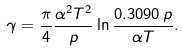Convert formula to latex. <formula><loc_0><loc_0><loc_500><loc_500>\gamma = \frac { \pi } { 4 } \frac { \alpha ^ { 2 } T ^ { 2 } } { p } \ln \frac { 0 . 3 0 9 0 \, p } { \alpha T } .</formula> 